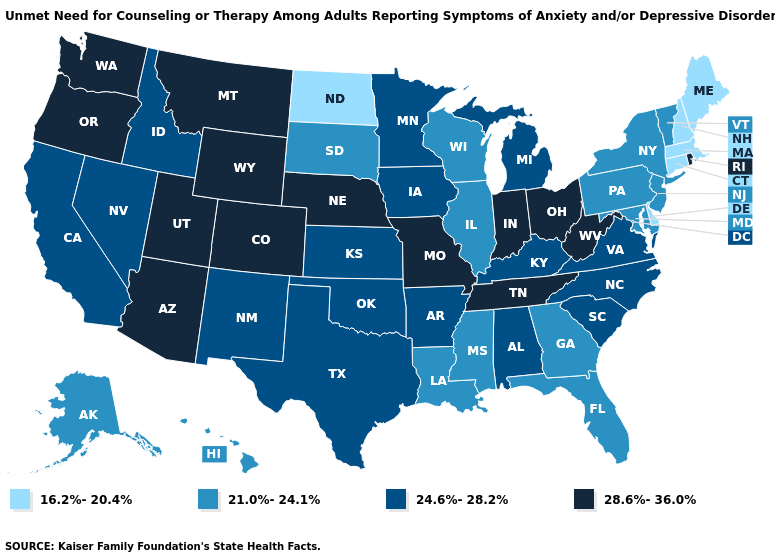Which states have the highest value in the USA?
Quick response, please. Arizona, Colorado, Indiana, Missouri, Montana, Nebraska, Ohio, Oregon, Rhode Island, Tennessee, Utah, Washington, West Virginia, Wyoming. Does Ohio have a lower value than Texas?
Short answer required. No. Name the states that have a value in the range 28.6%-36.0%?
Quick response, please. Arizona, Colorado, Indiana, Missouri, Montana, Nebraska, Ohio, Oregon, Rhode Island, Tennessee, Utah, Washington, West Virginia, Wyoming. What is the value of Idaho?
Answer briefly. 24.6%-28.2%. Name the states that have a value in the range 16.2%-20.4%?
Concise answer only. Connecticut, Delaware, Maine, Massachusetts, New Hampshire, North Dakota. What is the value of Tennessee?
Answer briefly. 28.6%-36.0%. Name the states that have a value in the range 28.6%-36.0%?
Write a very short answer. Arizona, Colorado, Indiana, Missouri, Montana, Nebraska, Ohio, Oregon, Rhode Island, Tennessee, Utah, Washington, West Virginia, Wyoming. Does the map have missing data?
Be succinct. No. What is the lowest value in the Northeast?
Keep it brief. 16.2%-20.4%. What is the value of Ohio?
Keep it brief. 28.6%-36.0%. Name the states that have a value in the range 28.6%-36.0%?
Concise answer only. Arizona, Colorado, Indiana, Missouri, Montana, Nebraska, Ohio, Oregon, Rhode Island, Tennessee, Utah, Washington, West Virginia, Wyoming. Name the states that have a value in the range 16.2%-20.4%?
Answer briefly. Connecticut, Delaware, Maine, Massachusetts, New Hampshire, North Dakota. Name the states that have a value in the range 21.0%-24.1%?
Quick response, please. Alaska, Florida, Georgia, Hawaii, Illinois, Louisiana, Maryland, Mississippi, New Jersey, New York, Pennsylvania, South Dakota, Vermont, Wisconsin. How many symbols are there in the legend?
Concise answer only. 4. 